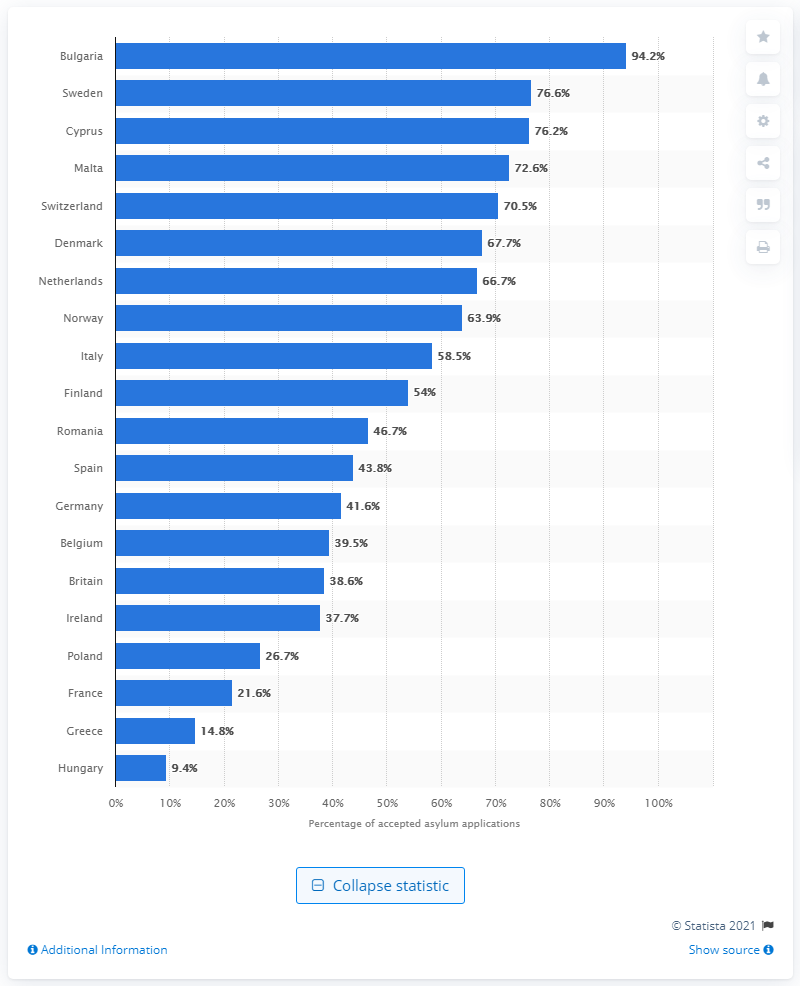Point out several critical features in this image. Bulgaria approved the highest percentage of asylum applicants in 2014 among all countries that year. 